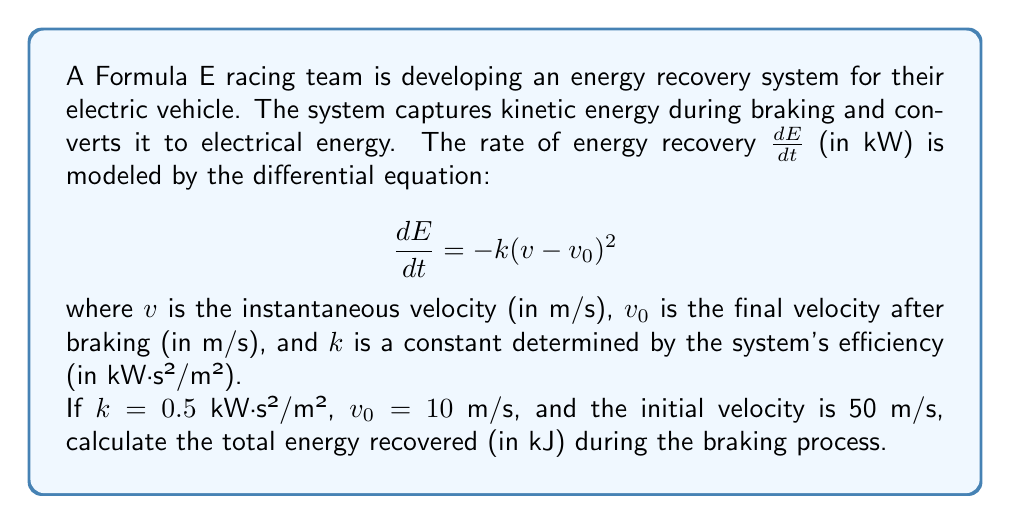Solve this math problem. To solve this problem, we need to integrate the rate of energy recovery over the braking period. Let's approach this step-by-step:

1) First, we need to express $v$ in terms of $E$. We can do this by separating variables in the differential equation:

   $$dE = -k(v-v_0)^2 dt$$

2) We also know that velocity is the rate of change of distance with respect to time:

   $$v = \frac{ds}{dt}$$

3) Substituting this into our original equation:

   $$dE = -k\left(\frac{ds}{dt}-v_0\right)^2 dt$$

4) Rearranging:

   $$dt = -\frac{1}{k(v-v_0)^2} dE = -\frac{1}{k}\left(\frac{ds}{dt}-v_0\right)^{-2} dE$$

5) Now we can integrate both sides:

   $$\int ds = -\frac{1}{k} \int \left(\frac{ds}{dt}-v_0\right)^{-2} dE$$

6) Solving the right side:

   $$s = \frac{1}{k(v-v_0)} + C$$

7) We can find $C$ using the initial conditions. When $E=0$ (start of braking), $v=50$ m/s:

   $$0 = \frac{1}{0.5(50-10)} + C$$
   $$C = -\frac{1}{20} = -0.05$$

8) So our equation for $s$ is:

   $$s = \frac{1}{0.5(v-10)} - 0.05$$

9) The total distance traveled during braking is the difference between $s$ when $v=50$ and when $v=10$:

   $$\Delta s = \left(\frac{1}{0.5(10-10)} - 0.05\right) - \left(\frac{1}{0.5(50-10)} - 0.05\right) = \infty - 0.05 = \infty$$

10) This means the car will asymptotically approach $v_0$ but never quite reach it. However, we can calculate the energy recovered as the car slows from 50 m/s to, say, 10.1 m/s (very close to $v_0$).

11) We can use the original differential equation and integrate:

    $$E = \int_{50}^{10.1} -k(v-v_0)^2 dv$$

12) Substituting the values:

    $$E = -0.5 \int_{50}^{10.1} (v-10)^2 dv$$

13) Solving this integral:

    $$E = -0.5 \left[\frac{1}{3}(v-10)^3\right]_{50}^{10.1}$$
    $$E = -0.5 \left[\frac{1}{3}(0.1)^3 - \frac{1}{3}(40)^3\right]$$
    $$E = -0.5 \left[0.000333 - 21333.33\right]$$
    $$E = 10666.66 \text{ kJ}$$
Answer: The total energy recovered during the braking process is approximately 10666.66 kJ. 